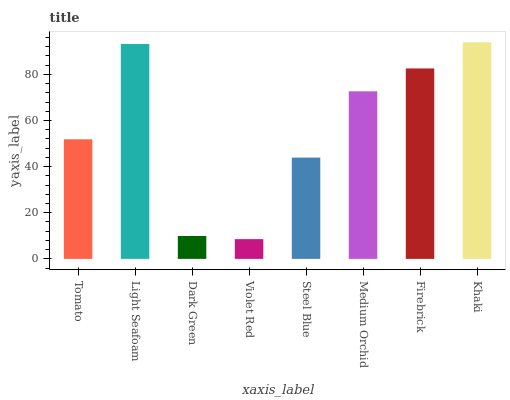Is Light Seafoam the minimum?
Answer yes or no. No. Is Light Seafoam the maximum?
Answer yes or no. No. Is Light Seafoam greater than Tomato?
Answer yes or no. Yes. Is Tomato less than Light Seafoam?
Answer yes or no. Yes. Is Tomato greater than Light Seafoam?
Answer yes or no. No. Is Light Seafoam less than Tomato?
Answer yes or no. No. Is Medium Orchid the high median?
Answer yes or no. Yes. Is Tomato the low median?
Answer yes or no. Yes. Is Light Seafoam the high median?
Answer yes or no. No. Is Medium Orchid the low median?
Answer yes or no. No. 